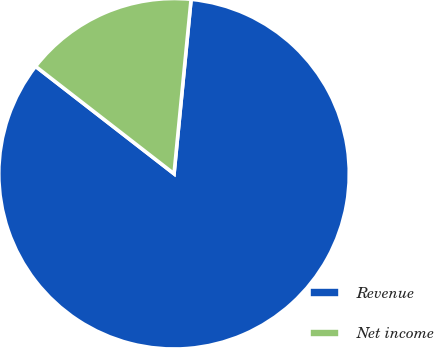<chart> <loc_0><loc_0><loc_500><loc_500><pie_chart><fcel>Revenue<fcel>Net income<nl><fcel>83.95%<fcel>16.05%<nl></chart> 